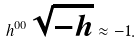Convert formula to latex. <formula><loc_0><loc_0><loc_500><loc_500>h ^ { 0 0 } \sqrt { - h } \approx - 1 .</formula> 